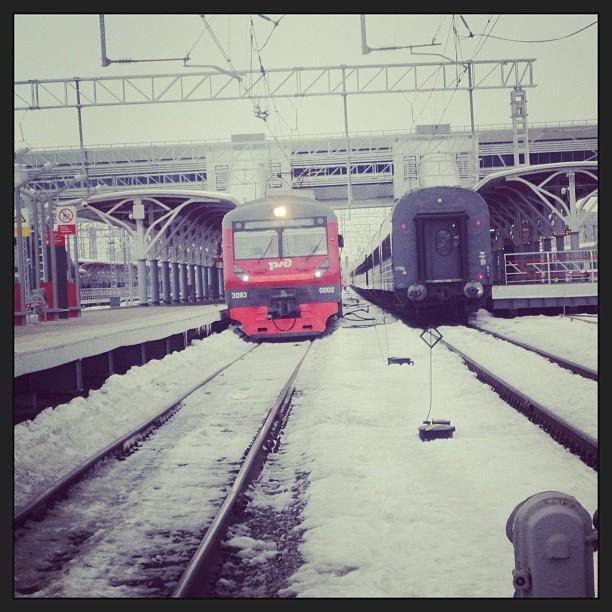How many trains are there?
Give a very brief answer. 2. How many trains are visible?
Give a very brief answer. 2. 